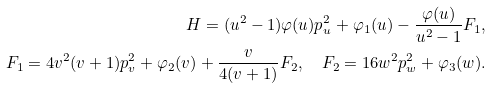<formula> <loc_0><loc_0><loc_500><loc_500>H = ( u ^ { 2 } - 1 ) \varphi ( u ) p _ { u } ^ { 2 } + \varphi _ { 1 } ( u ) - \frac { \varphi ( u ) } { u ^ { 2 } - 1 } F _ { 1 } , \\ F _ { 1 } = 4 v ^ { 2 } ( v + 1 ) p _ { v } ^ { 2 } + \varphi _ { 2 } ( v ) + \frac { v } { 4 ( v + 1 ) } F _ { 2 } , \quad F _ { 2 } = 1 6 w ^ { 2 } p _ { w } ^ { 2 } + \varphi _ { 3 } ( w ) .</formula> 